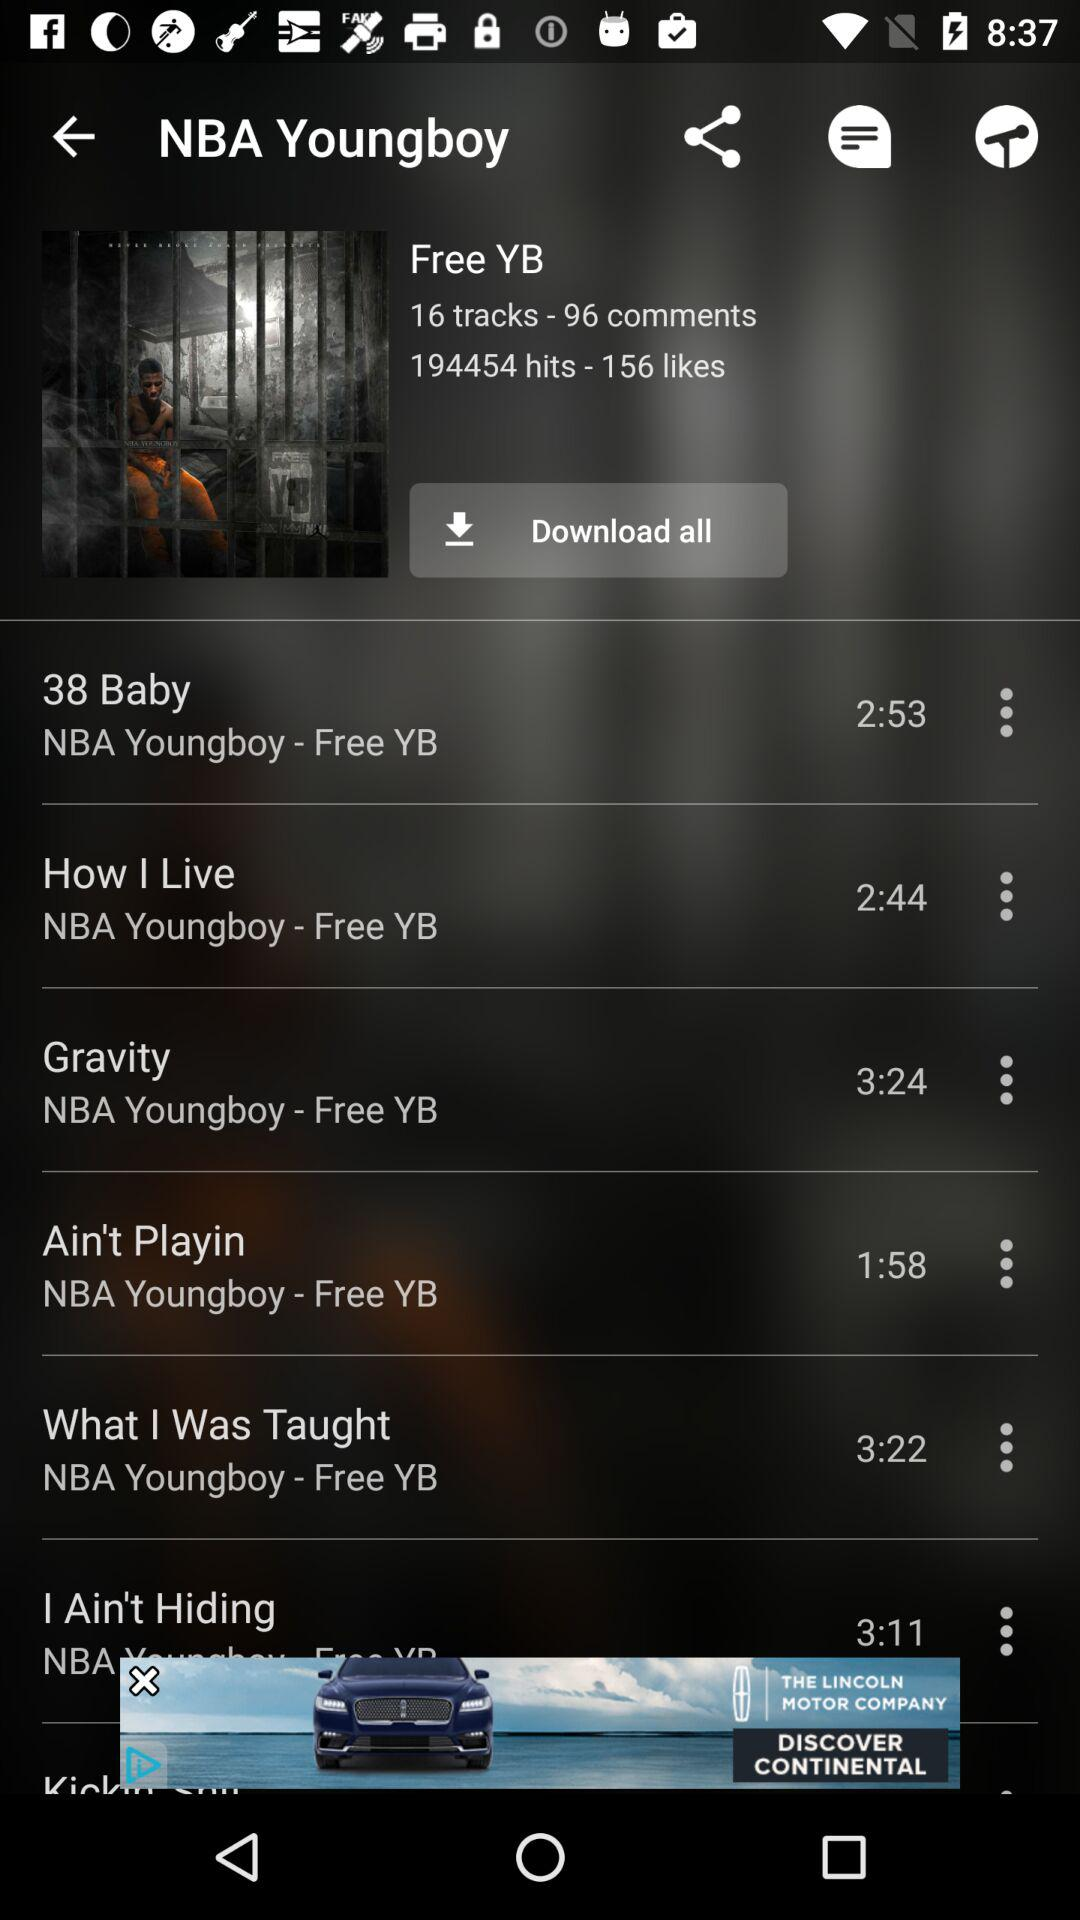How many likes are there? There are 156 likes. 